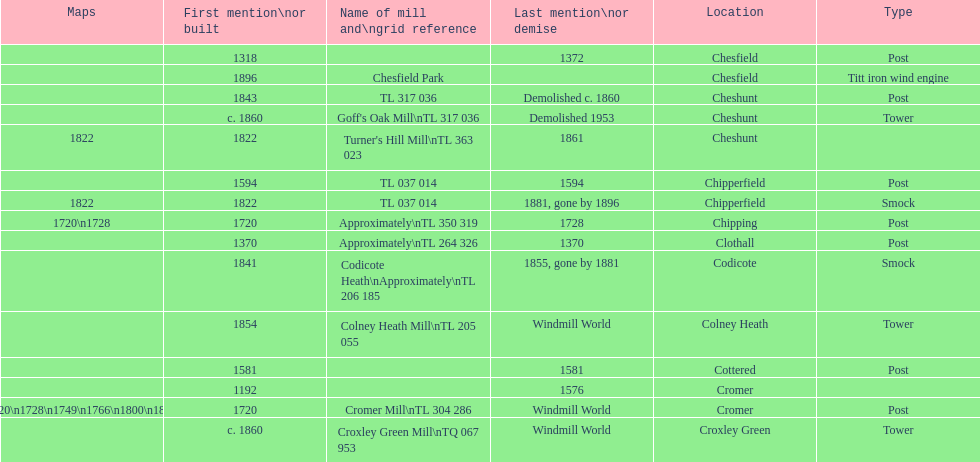What is the name of the only "c" mill located in colney health? Colney Heath Mill. 